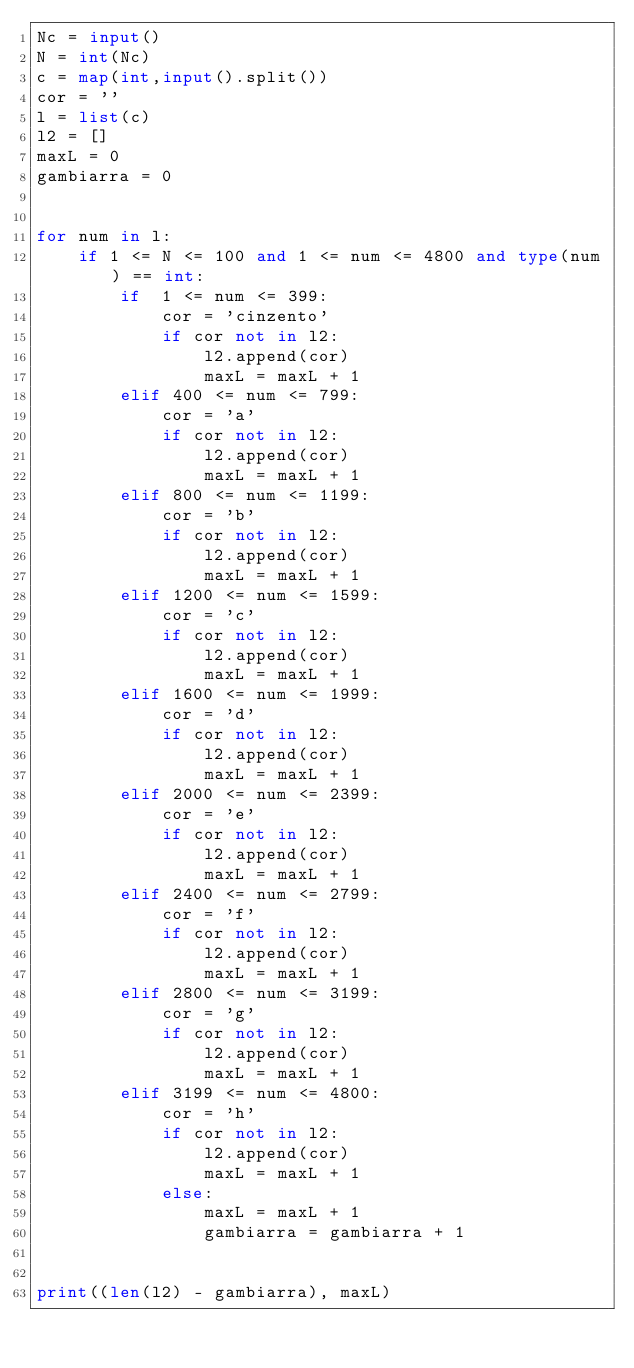<code> <loc_0><loc_0><loc_500><loc_500><_Python_>Nc = input()
N = int(Nc)
c = map(int,input().split())
cor = ''
l = list(c)
l2 = []
maxL = 0
gambiarra = 0


for num in l:
    if 1 <= N <= 100 and 1 <= num <= 4800 and type(num) == int:
        if  1 <= num <= 399:
            cor = 'cinzento'
            if cor not in l2:
                l2.append(cor)
                maxL = maxL + 1
        elif 400 <= num <= 799:
            cor = 'a'
            if cor not in l2:
                l2.append(cor)
                maxL = maxL + 1
        elif 800 <= num <= 1199:
            cor = 'b'
            if cor not in l2:
                l2.append(cor)
                maxL = maxL + 1
        elif 1200 <= num <= 1599:
            cor = 'c'
            if cor not in l2:
                l2.append(cor)
                maxL = maxL + 1
        elif 1600 <= num <= 1999:
            cor = 'd'
            if cor not in l2:
                l2.append(cor)
                maxL = maxL + 1
        elif 2000 <= num <= 2399:
            cor = 'e'
            if cor not in l2:
                l2.append(cor)
                maxL = maxL + 1
        elif 2400 <= num <= 2799:
            cor = 'f'
            if cor not in l2:
                l2.append(cor)
                maxL = maxL + 1
        elif 2800 <= num <= 3199:
            cor = 'g'
            if cor not in l2:
                l2.append(cor)
                maxL = maxL + 1
        elif 3199 <= num <= 4800:
            cor = 'h'
            if cor not in l2:
                l2.append(cor)
                maxL = maxL + 1
            else:
                maxL = maxL + 1
                gambiarra = gambiarra + 1
            
           
print((len(l2) - gambiarra), maxL)</code> 